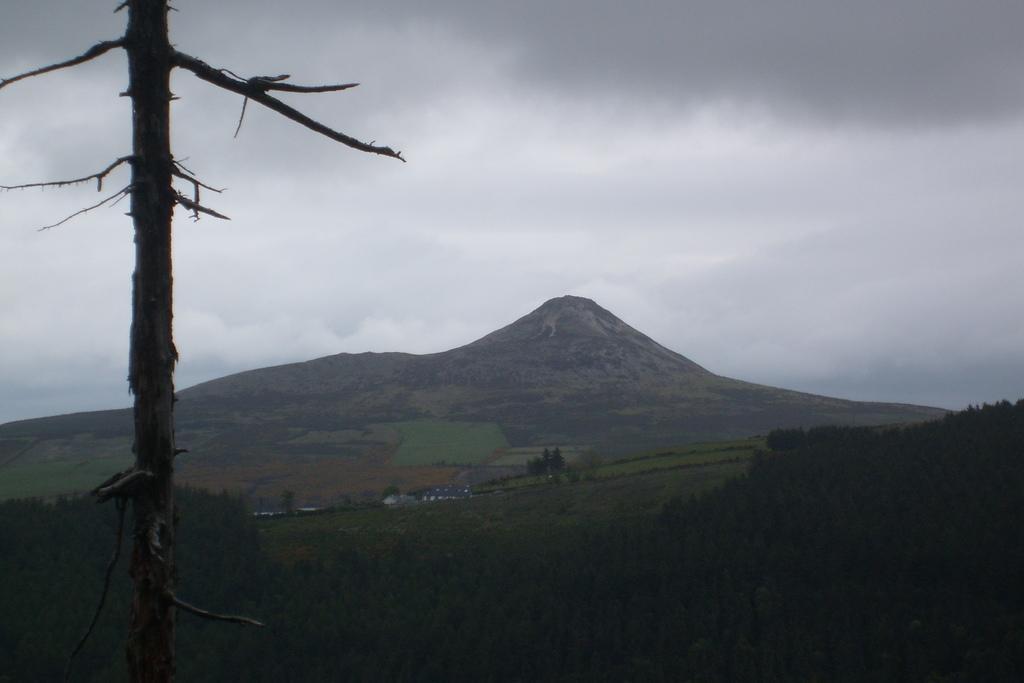Please provide a concise description of this image. In this picture I can see a hill and few trees and a tree bark on the side and a cloudy Sky. 